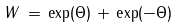Convert formula to latex. <formula><loc_0><loc_0><loc_500><loc_500>W \, = \, \exp ( \Theta ) \, + \, \exp ( - \Theta )</formula> 